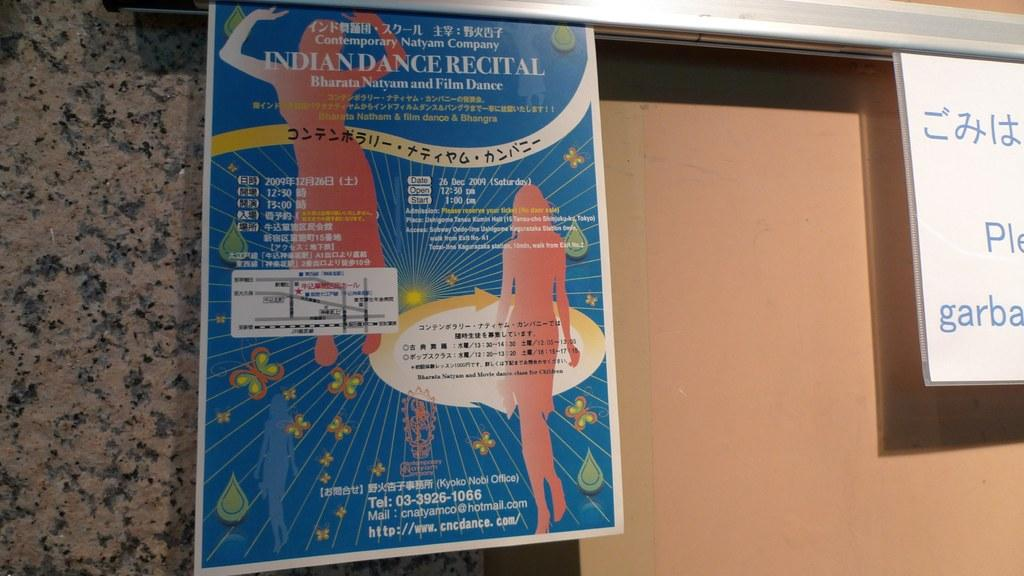<image>
Describe the image concisely. A posted flyer advertising an Indian Dance Recital. 